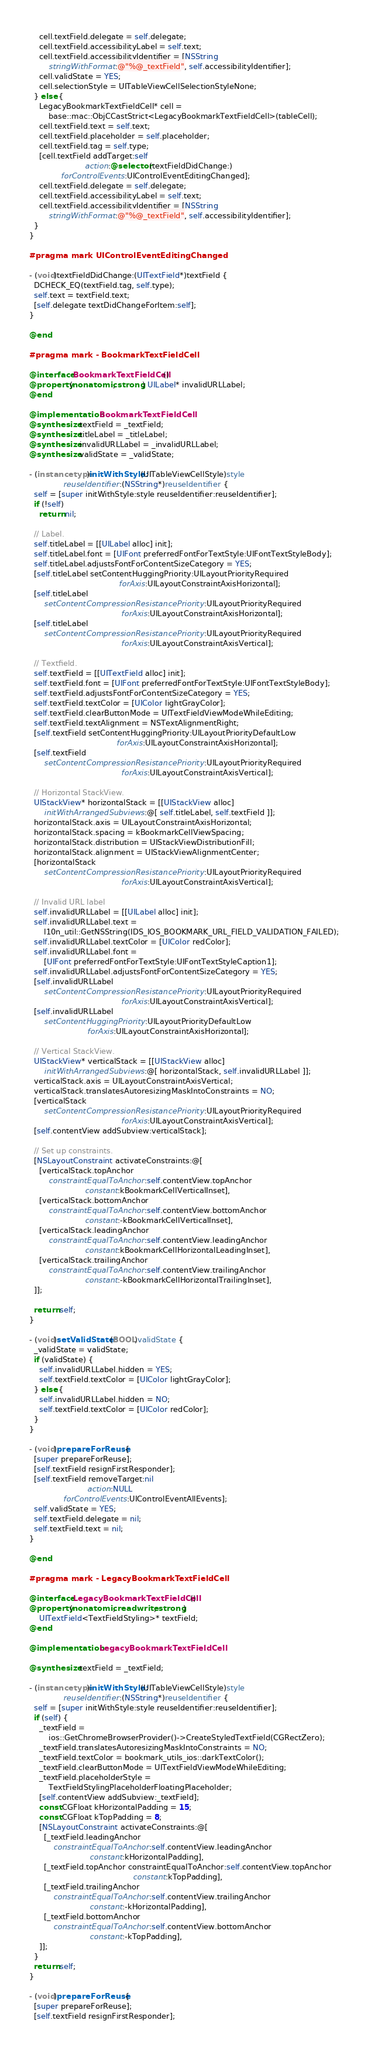<code> <loc_0><loc_0><loc_500><loc_500><_ObjectiveC_>    cell.textField.delegate = self.delegate;
    cell.textField.accessibilityLabel = self.text;
    cell.textField.accessibilityIdentifier = [NSString
        stringWithFormat:@"%@_textField", self.accessibilityIdentifier];
    cell.validState = YES;
    cell.selectionStyle = UITableViewCellSelectionStyleNone;
  } else {
    LegacyBookmarkTextFieldCell* cell =
        base::mac::ObjCCastStrict<LegacyBookmarkTextFieldCell>(tableCell);
    cell.textField.text = self.text;
    cell.textField.placeholder = self.placeholder;
    cell.textField.tag = self.type;
    [cell.textField addTarget:self
                       action:@selector(textFieldDidChange:)
             forControlEvents:UIControlEventEditingChanged];
    cell.textField.delegate = self.delegate;
    cell.textField.accessibilityLabel = self.text;
    cell.textField.accessibilityIdentifier = [NSString
        stringWithFormat:@"%@_textField", self.accessibilityIdentifier];
  }
}

#pragma mark UIControlEventEditingChanged

- (void)textFieldDidChange:(UITextField*)textField {
  DCHECK_EQ(textField.tag, self.type);
  self.text = textField.text;
  [self.delegate textDidChangeForItem:self];
}

@end

#pragma mark - BookmarkTextFieldCell

@interface BookmarkTextFieldCell ()
@property(nonatomic, strong) UILabel* invalidURLLabel;
@end

@implementation BookmarkTextFieldCell
@synthesize textField = _textField;
@synthesize titleLabel = _titleLabel;
@synthesize invalidURLLabel = _invalidURLLabel;
@synthesize validState = _validState;

- (instancetype)initWithStyle:(UITableViewCellStyle)style
              reuseIdentifier:(NSString*)reuseIdentifier {
  self = [super initWithStyle:style reuseIdentifier:reuseIdentifier];
  if (!self)
    return nil;

  // Label.
  self.titleLabel = [[UILabel alloc] init];
  self.titleLabel.font = [UIFont preferredFontForTextStyle:UIFontTextStyleBody];
  self.titleLabel.adjustsFontForContentSizeCategory = YES;
  [self.titleLabel setContentHuggingPriority:UILayoutPriorityRequired
                                     forAxis:UILayoutConstraintAxisHorizontal];
  [self.titleLabel
      setContentCompressionResistancePriority:UILayoutPriorityRequired
                                      forAxis:UILayoutConstraintAxisHorizontal];
  [self.titleLabel
      setContentCompressionResistancePriority:UILayoutPriorityRequired
                                      forAxis:UILayoutConstraintAxisVertical];

  // Textfield.
  self.textField = [[UITextField alloc] init];
  self.textField.font = [UIFont preferredFontForTextStyle:UIFontTextStyleBody];
  self.textField.adjustsFontForContentSizeCategory = YES;
  self.textField.textColor = [UIColor lightGrayColor];
  self.textField.clearButtonMode = UITextFieldViewModeWhileEditing;
  self.textField.textAlignment = NSTextAlignmentRight;
  [self.textField setContentHuggingPriority:UILayoutPriorityDefaultLow
                                    forAxis:UILayoutConstraintAxisHorizontal];
  [self.textField
      setContentCompressionResistancePriority:UILayoutPriorityRequired
                                      forAxis:UILayoutConstraintAxisVertical];

  // Horizontal StackView.
  UIStackView* horizontalStack = [[UIStackView alloc]
      initWithArrangedSubviews:@[ self.titleLabel, self.textField ]];
  horizontalStack.axis = UILayoutConstraintAxisHorizontal;
  horizontalStack.spacing = kBookmarkCellViewSpacing;
  horizontalStack.distribution = UIStackViewDistributionFill;
  horizontalStack.alignment = UIStackViewAlignmentCenter;
  [horizontalStack
      setContentCompressionResistancePriority:UILayoutPriorityRequired
                                      forAxis:UILayoutConstraintAxisVertical];

  // Invalid URL label
  self.invalidURLLabel = [[UILabel alloc] init];
  self.invalidURLLabel.text =
      l10n_util::GetNSString(IDS_IOS_BOOKMARK_URL_FIELD_VALIDATION_FAILED);
  self.invalidURLLabel.textColor = [UIColor redColor];
  self.invalidURLLabel.font =
      [UIFont preferredFontForTextStyle:UIFontTextStyleCaption1];
  self.invalidURLLabel.adjustsFontForContentSizeCategory = YES;
  [self.invalidURLLabel
      setContentCompressionResistancePriority:UILayoutPriorityRequired
                                      forAxis:UILayoutConstraintAxisVertical];
  [self.invalidURLLabel
      setContentHuggingPriority:UILayoutPriorityDefaultLow
                        forAxis:UILayoutConstraintAxisHorizontal];

  // Vertical StackView.
  UIStackView* verticalStack = [[UIStackView alloc]
      initWithArrangedSubviews:@[ horizontalStack, self.invalidURLLabel ]];
  verticalStack.axis = UILayoutConstraintAxisVertical;
  verticalStack.translatesAutoresizingMaskIntoConstraints = NO;
  [verticalStack
      setContentCompressionResistancePriority:UILayoutPriorityRequired
                                      forAxis:UILayoutConstraintAxisVertical];
  [self.contentView addSubview:verticalStack];

  // Set up constraints.
  [NSLayoutConstraint activateConstraints:@[
    [verticalStack.topAnchor
        constraintEqualToAnchor:self.contentView.topAnchor
                       constant:kBookmarkCellVerticalInset],
    [verticalStack.bottomAnchor
        constraintEqualToAnchor:self.contentView.bottomAnchor
                       constant:-kBookmarkCellVerticalInset],
    [verticalStack.leadingAnchor
        constraintEqualToAnchor:self.contentView.leadingAnchor
                       constant:kBookmarkCellHorizontalLeadingInset],
    [verticalStack.trailingAnchor
        constraintEqualToAnchor:self.contentView.trailingAnchor
                       constant:-kBookmarkCellHorizontalTrailingInset],
  ]];

  return self;
}

- (void)setValidState:(BOOL)validState {
  _validState = validState;
  if (validState) {
    self.invalidURLLabel.hidden = YES;
    self.textField.textColor = [UIColor lightGrayColor];
  } else {
    self.invalidURLLabel.hidden = NO;
    self.textField.textColor = [UIColor redColor];
  }
}

- (void)prepareForReuse {
  [super prepareForReuse];
  [self.textField resignFirstResponder];
  [self.textField removeTarget:nil
                        action:NULL
              forControlEvents:UIControlEventAllEvents];
  self.validState = YES;
  self.textField.delegate = nil;
  self.textField.text = nil;
}

@end

#pragma mark - LegacyBookmarkTextFieldCell

@interface LegacyBookmarkTextFieldCell ()
@property(nonatomic, readwrite, strong)
    UITextField<TextFieldStyling>* textField;
@end

@implementation LegacyBookmarkTextFieldCell

@synthesize textField = _textField;

- (instancetype)initWithStyle:(UITableViewCellStyle)style
              reuseIdentifier:(NSString*)reuseIdentifier {
  self = [super initWithStyle:style reuseIdentifier:reuseIdentifier];
  if (self) {
    _textField =
        ios::GetChromeBrowserProvider()->CreateStyledTextField(CGRectZero);
    _textField.translatesAutoresizingMaskIntoConstraints = NO;
    _textField.textColor = bookmark_utils_ios::darkTextColor();
    _textField.clearButtonMode = UITextFieldViewModeWhileEditing;
    _textField.placeholderStyle =
        TextFieldStylingPlaceholderFloatingPlaceholder;
    [self.contentView addSubview:_textField];
    const CGFloat kHorizontalPadding = 15;
    const CGFloat kTopPadding = 8;
    [NSLayoutConstraint activateConstraints:@[
      [_textField.leadingAnchor
          constraintEqualToAnchor:self.contentView.leadingAnchor
                         constant:kHorizontalPadding],
      [_textField.topAnchor constraintEqualToAnchor:self.contentView.topAnchor
                                           constant:kTopPadding],
      [_textField.trailingAnchor
          constraintEqualToAnchor:self.contentView.trailingAnchor
                         constant:-kHorizontalPadding],
      [_textField.bottomAnchor
          constraintEqualToAnchor:self.contentView.bottomAnchor
                         constant:-kTopPadding],
    ]];
  }
  return self;
}

- (void)prepareForReuse {
  [super prepareForReuse];
  [self.textField resignFirstResponder];</code> 